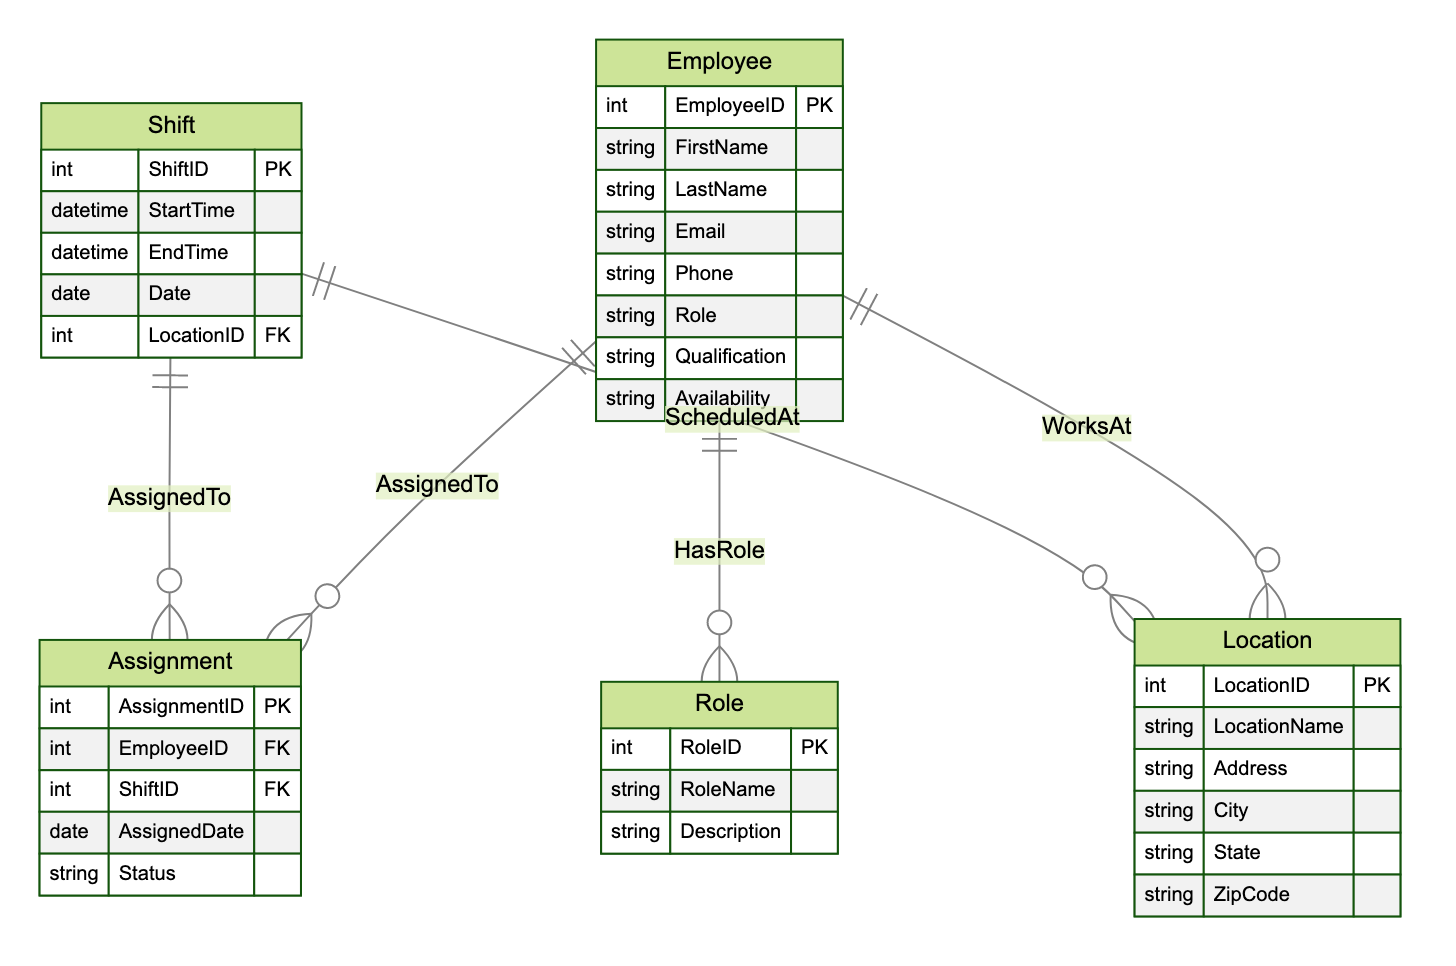What is the primary key of the Employee entity? The primary key of the Employee entity is EmployeeID, which uniquely identifies each employee in the database.
Answer: EmployeeID How many relationships involve the Shift entity? The Shift entity is involved in two relationships: "AssignedTo" with Employee for assignments and "ScheduledAt" with Location for its schedules.
Answer: 2 What is an attribute of the Assignment entity? The Assignment entity has several attributes, one of which is AssignmentID, which serves as its primary key.
Answer: AssignmentID Which entity has a relationship with both Employee and Location? The entity that has a relationship with both Employee and Location is "WorksAt," as it defines where each employee works.
Answer: WorksAt What is one attribute of the Shift entity? The Shift entity includes several attributes, one of which is StartTime, specifying when the shift begins.
Answer: StartTime What type of relationship connects the Employee and Role entities? The relationship connecting Employee and Role entities is called "HasRole," which indicates the specific role assigned to each employee.
Answer: HasRole How many attributes does the Location entity have? The Location entity consists of six attributes, including LocationID, LocationName, Address, City, State, and ZipCode.
Answer: 6 What is the relationship status between Assignment and Shift entities? The Assignment and Shift entities are connected through the "AssignedTo" relationship, where each assignment links specific employees to their respective shifts.
Answer: AssignedTo What type of information does the Availability attribute refer to in the Employee entity? The Availability attribute in the Employee entity refers to the times during which an employee is available to work, indicating their scheduling options.
Answer: Availability 